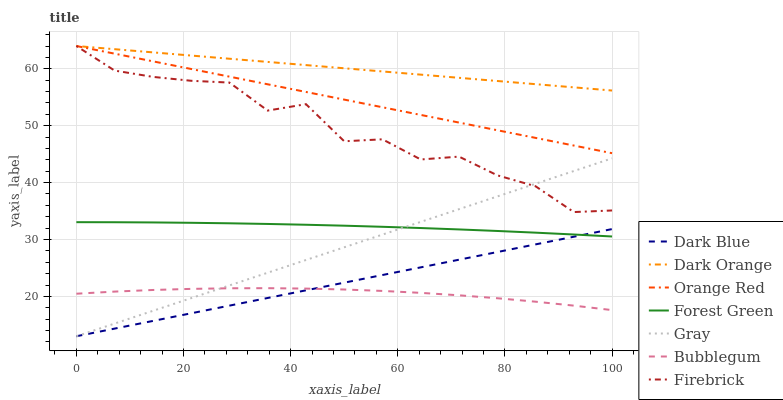Does Bubblegum have the minimum area under the curve?
Answer yes or no. Yes. Does Dark Orange have the maximum area under the curve?
Answer yes or no. Yes. Does Firebrick have the minimum area under the curve?
Answer yes or no. No. Does Firebrick have the maximum area under the curve?
Answer yes or no. No. Is Dark Blue the smoothest?
Answer yes or no. Yes. Is Firebrick the roughest?
Answer yes or no. Yes. Is Dark Orange the smoothest?
Answer yes or no. No. Is Dark Orange the roughest?
Answer yes or no. No. Does Firebrick have the lowest value?
Answer yes or no. No. Does Bubblegum have the highest value?
Answer yes or no. No. Is Bubblegum less than Dark Orange?
Answer yes or no. Yes. Is Firebrick greater than Bubblegum?
Answer yes or no. Yes. Does Bubblegum intersect Dark Orange?
Answer yes or no. No. 